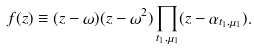Convert formula to latex. <formula><loc_0><loc_0><loc_500><loc_500>f ( z ) \equiv ( z - \omega ) ( z - \omega ^ { 2 } ) \prod _ { t _ { 1 } , \mu _ { 1 } } ( z - \alpha _ { t _ { 1 } , \mu _ { 1 } } ) .</formula> 